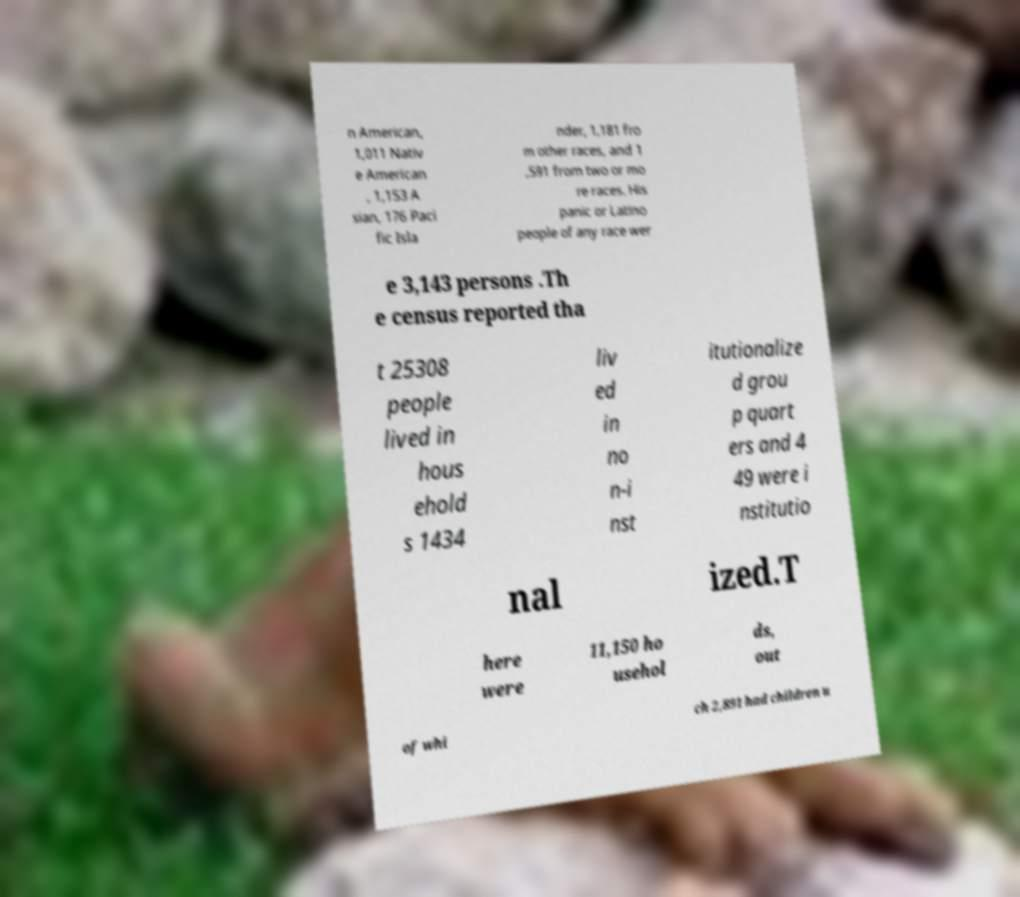Can you accurately transcribe the text from the provided image for me? n American, 1,011 Nativ e American , 1,153 A sian, 176 Paci fic Isla nder, 1,181 fro m other races, and 1 ,591 from two or mo re races. His panic or Latino people of any race wer e 3,143 persons .Th e census reported tha t 25308 people lived in hous ehold s 1434 liv ed in no n-i nst itutionalize d grou p quart ers and 4 49 were i nstitutio nal ized.T here were 11,150 ho usehol ds, out of whi ch 2,891 had children u 